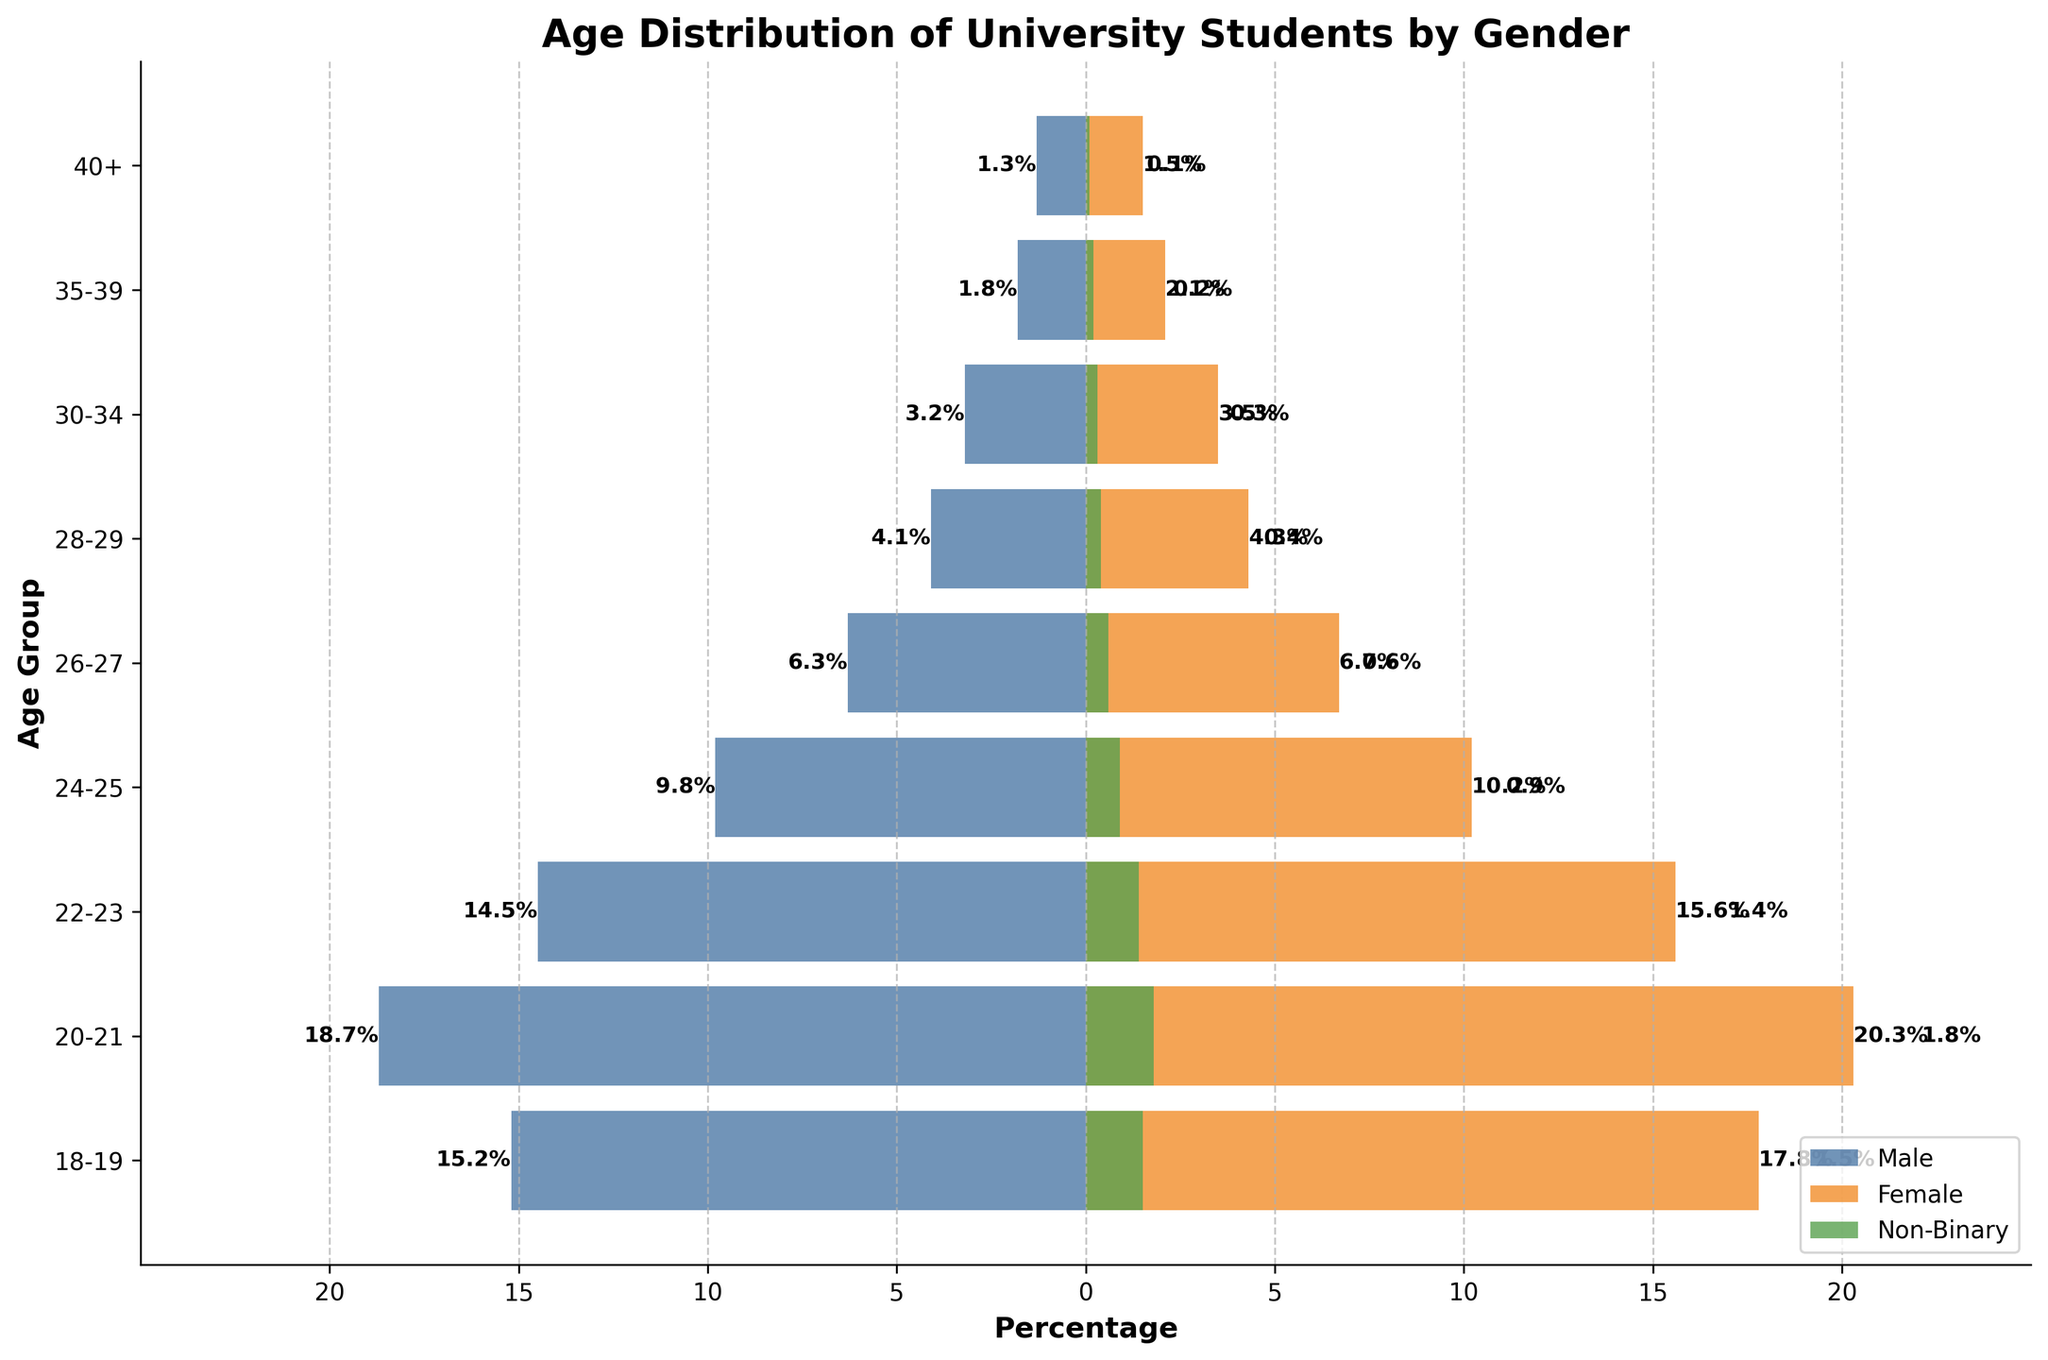What is the title of the figure? The title of the figure is displayed at the top and usually summarizes the main theme of the plot. Here, it clearly states the content being represented in the figure.
Answer: Age Distribution of University Students by Gender Which age group has the highest percentage of female students? By looking at the orange bars representing female students, we can see which age group has the longest bar, indicating the highest percentage. The 20-21 age group has the longest orange bar.
Answer: 20-21 Compare the percentage of male and female students in the 22-23 age group. Which is higher, and by how much? Look at the length of the bars in the 22-23 age group. According to the figure, the female percentage (15.6%) is higher than the male percentage (14.5%). The difference is 15.6% - 14.5% = 1.1%.
Answer: Female is higher by 1.1% What is the percentage of non-binary students in the 24-25 age group? Locate the 24-25 age group and identify the green bar, which represents non-binary students. Its value is labeled at the end of the bar.
Answer: 0.9% Which age group has the smallest percentage of male students? The age groups represented by the blue bars indicate male students. By comparing the lengths of the blue bars, the 40+ age group has the smallest percentage.
Answer: 40+ What is the sum of female and non-binary students' percentages in the 26-27 age group? The figure provides both the female and non-binary percentages for the 26-27 age group. Sum these values: 6.7% (female) + 0.6% (non-binary) = 7.3%.
Answer: 7.3% Is the percentage of male students in the 18-19 age group greater than the percentage in the 28-29 age group? Compare the length of the blue bars for the 18-19 and 28-29 age groups. The bar for 18-19 (15.2%) is longer than the bar for 28-29 (4.1%).
Answer: Yes, 15.2% > 4.1% Which age group has a nearly equal percentage of male and female students? By comparing the lengths of the blue and orange bars, the 24-25 and 26-27 age groups appear to be close. However, 24-25 (Male: 9.8%, Female: 10.2%) seems the closest.
Answer: 24-25 What percentage of students are non-binary in the oldest age group? The oldest age group is 40+. The green bar in this group represents non-binary students and it is labeled.
Answer: 0.1% How does the distribution of non-binary students compare across different age groups? Analyzing the green bars across the age groups, the non-binary percentage is highest in the 20-21 age group and lowest in the 40+ age group. The trend shows a decrease as the age increases.
Answer: Highest in 20-21, lowest in 40+ 